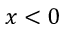Convert formula to latex. <formula><loc_0><loc_0><loc_500><loc_500>x < 0</formula> 